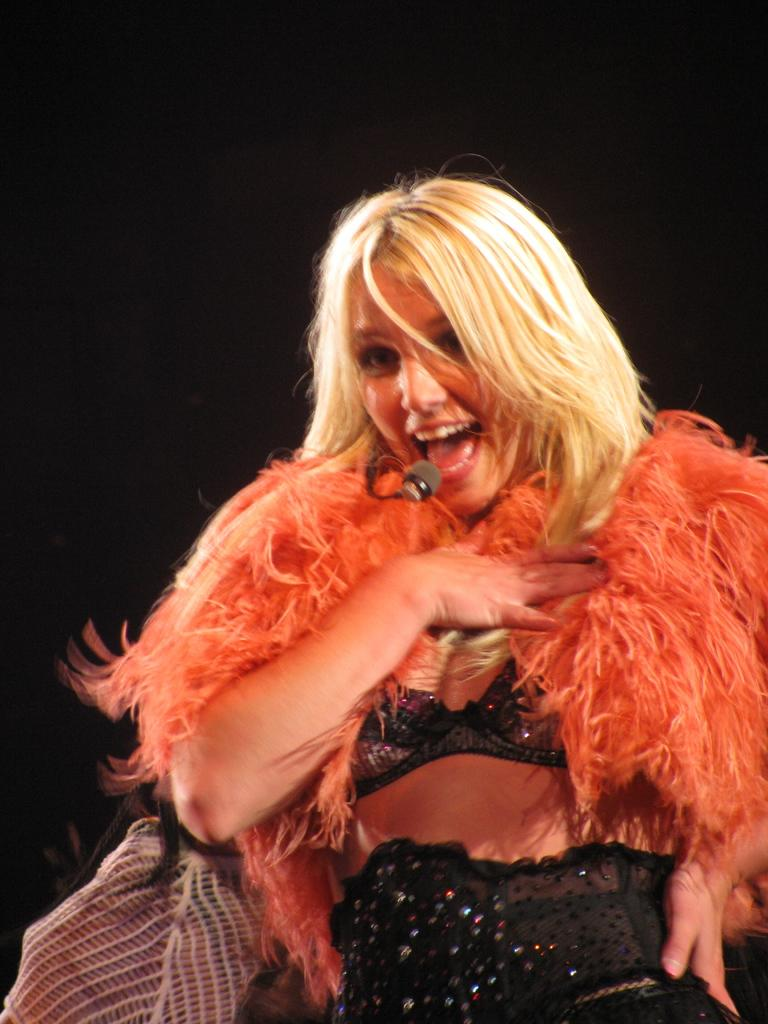Who is the main subject in the image? There is a woman in the image. What is the woman doing in the image? The woman is singing. What tool is the woman using while singing? The woman is using a microphone. What can be observed about the background of the image? The background of the image is dark. What type of jewel is the woman wearing on her uncle's channel in the image? There is no uncle, channel, or jewel mentioned in the image. The image only features a woman singing with a microphone, and the background is dark. 